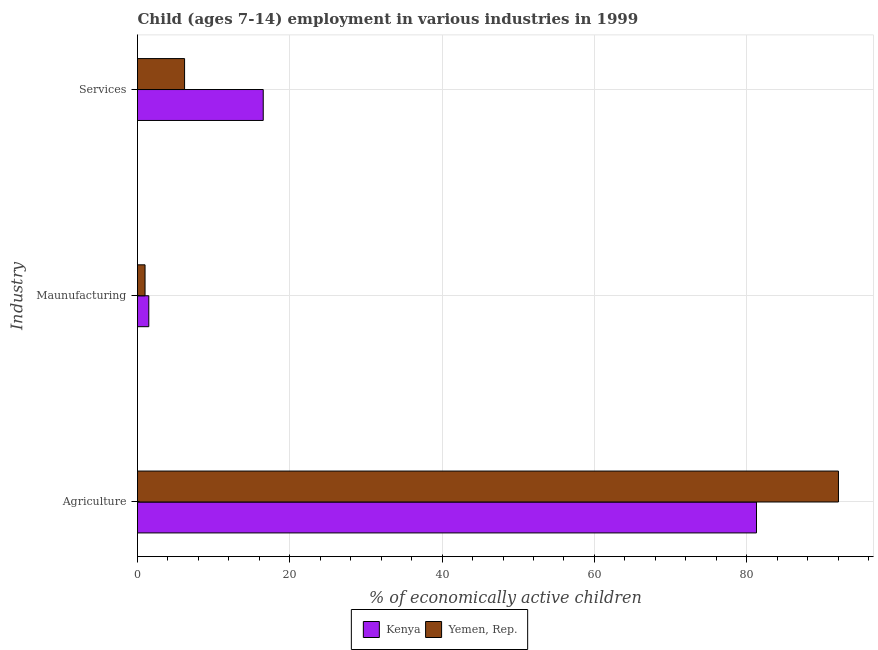How many bars are there on the 2nd tick from the top?
Provide a short and direct response. 2. How many bars are there on the 3rd tick from the bottom?
Ensure brevity in your answer.  2. What is the label of the 1st group of bars from the top?
Offer a terse response. Services. What is the percentage of economically active children in agriculture in Kenya?
Your response must be concise. 81.28. Across all countries, what is the maximum percentage of economically active children in manufacturing?
Make the answer very short. 1.48. Across all countries, what is the minimum percentage of economically active children in services?
Your answer should be compact. 6.18. In which country was the percentage of economically active children in manufacturing maximum?
Make the answer very short. Kenya. In which country was the percentage of economically active children in manufacturing minimum?
Offer a terse response. Yemen, Rep. What is the total percentage of economically active children in services in the graph?
Offer a terse response. 22.69. What is the difference between the percentage of economically active children in manufacturing in Yemen, Rep. and that in Kenya?
Make the answer very short. -0.49. What is the difference between the percentage of economically active children in services in Yemen, Rep. and the percentage of economically active children in manufacturing in Kenya?
Ensure brevity in your answer.  4.7. What is the average percentage of economically active children in agriculture per country?
Provide a succinct answer. 86.66. What is the difference between the percentage of economically active children in services and percentage of economically active children in agriculture in Yemen, Rep.?
Your response must be concise. -85.86. What is the ratio of the percentage of economically active children in services in Kenya to that in Yemen, Rep.?
Your answer should be compact. 2.67. Is the percentage of economically active children in agriculture in Kenya less than that in Yemen, Rep.?
Your answer should be very brief. Yes. Is the difference between the percentage of economically active children in manufacturing in Kenya and Yemen, Rep. greater than the difference between the percentage of economically active children in services in Kenya and Yemen, Rep.?
Offer a very short reply. No. What is the difference between the highest and the second highest percentage of economically active children in agriculture?
Give a very brief answer. 10.76. What is the difference between the highest and the lowest percentage of economically active children in manufacturing?
Offer a very short reply. 0.49. Is the sum of the percentage of economically active children in services in Kenya and Yemen, Rep. greater than the maximum percentage of economically active children in agriculture across all countries?
Your response must be concise. No. What does the 1st bar from the top in Maunufacturing represents?
Make the answer very short. Yemen, Rep. What does the 1st bar from the bottom in Services represents?
Offer a terse response. Kenya. How many bars are there?
Your response must be concise. 6. Are all the bars in the graph horizontal?
Make the answer very short. Yes. Does the graph contain any zero values?
Your answer should be very brief. No. What is the title of the graph?
Give a very brief answer. Child (ages 7-14) employment in various industries in 1999. What is the label or title of the X-axis?
Your answer should be very brief. % of economically active children. What is the label or title of the Y-axis?
Your answer should be very brief. Industry. What is the % of economically active children of Kenya in Agriculture?
Your response must be concise. 81.28. What is the % of economically active children in Yemen, Rep. in Agriculture?
Make the answer very short. 92.04. What is the % of economically active children in Kenya in Maunufacturing?
Ensure brevity in your answer.  1.48. What is the % of economically active children of Kenya in Services?
Your answer should be very brief. 16.51. What is the % of economically active children in Yemen, Rep. in Services?
Give a very brief answer. 6.18. Across all Industry, what is the maximum % of economically active children of Kenya?
Offer a very short reply. 81.28. Across all Industry, what is the maximum % of economically active children of Yemen, Rep.?
Offer a terse response. 92.04. Across all Industry, what is the minimum % of economically active children of Kenya?
Your response must be concise. 1.48. What is the total % of economically active children of Kenya in the graph?
Your response must be concise. 99.27. What is the total % of economically active children in Yemen, Rep. in the graph?
Offer a terse response. 99.21. What is the difference between the % of economically active children in Kenya in Agriculture and that in Maunufacturing?
Your response must be concise. 79.8. What is the difference between the % of economically active children of Yemen, Rep. in Agriculture and that in Maunufacturing?
Your response must be concise. 91.05. What is the difference between the % of economically active children of Kenya in Agriculture and that in Services?
Keep it short and to the point. 64.77. What is the difference between the % of economically active children of Yemen, Rep. in Agriculture and that in Services?
Offer a terse response. 85.86. What is the difference between the % of economically active children in Kenya in Maunufacturing and that in Services?
Provide a short and direct response. -15.03. What is the difference between the % of economically active children of Yemen, Rep. in Maunufacturing and that in Services?
Provide a short and direct response. -5.19. What is the difference between the % of economically active children in Kenya in Agriculture and the % of economically active children in Yemen, Rep. in Maunufacturing?
Ensure brevity in your answer.  80.29. What is the difference between the % of economically active children in Kenya in Agriculture and the % of economically active children in Yemen, Rep. in Services?
Your answer should be compact. 75.1. What is the difference between the % of economically active children in Kenya in Maunufacturing and the % of economically active children in Yemen, Rep. in Services?
Keep it short and to the point. -4.7. What is the average % of economically active children in Kenya per Industry?
Your answer should be very brief. 33.09. What is the average % of economically active children of Yemen, Rep. per Industry?
Give a very brief answer. 33.07. What is the difference between the % of economically active children in Kenya and % of economically active children in Yemen, Rep. in Agriculture?
Provide a short and direct response. -10.76. What is the difference between the % of economically active children of Kenya and % of economically active children of Yemen, Rep. in Maunufacturing?
Your answer should be compact. 0.49. What is the difference between the % of economically active children in Kenya and % of economically active children in Yemen, Rep. in Services?
Your answer should be compact. 10.33. What is the ratio of the % of economically active children in Kenya in Agriculture to that in Maunufacturing?
Offer a very short reply. 54.84. What is the ratio of the % of economically active children in Yemen, Rep. in Agriculture to that in Maunufacturing?
Give a very brief answer. 92.97. What is the ratio of the % of economically active children of Kenya in Agriculture to that in Services?
Offer a terse response. 4.92. What is the ratio of the % of economically active children of Yemen, Rep. in Agriculture to that in Services?
Offer a very short reply. 14.89. What is the ratio of the % of economically active children in Kenya in Maunufacturing to that in Services?
Give a very brief answer. 0.09. What is the ratio of the % of economically active children in Yemen, Rep. in Maunufacturing to that in Services?
Keep it short and to the point. 0.16. What is the difference between the highest and the second highest % of economically active children of Kenya?
Your answer should be compact. 64.77. What is the difference between the highest and the second highest % of economically active children in Yemen, Rep.?
Provide a short and direct response. 85.86. What is the difference between the highest and the lowest % of economically active children of Kenya?
Your answer should be compact. 79.8. What is the difference between the highest and the lowest % of economically active children of Yemen, Rep.?
Offer a terse response. 91.05. 